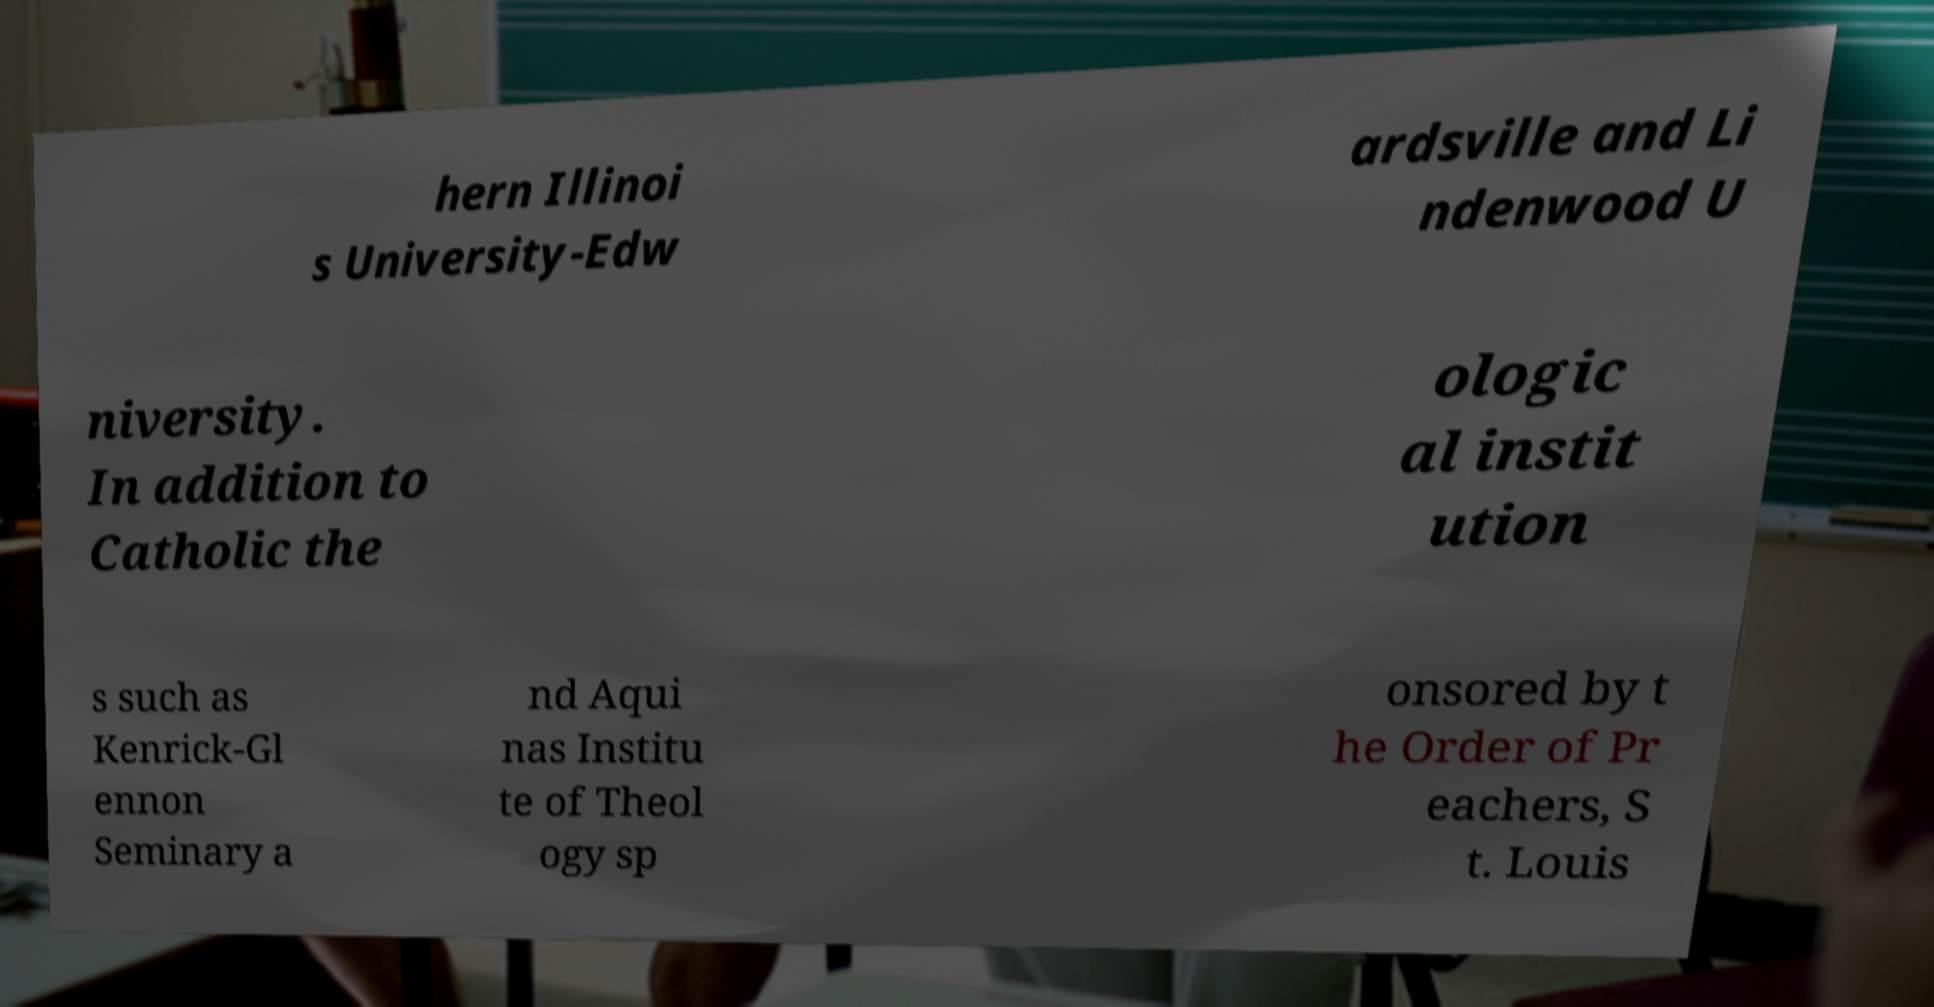For documentation purposes, I need the text within this image transcribed. Could you provide that? hern Illinoi s University-Edw ardsville and Li ndenwood U niversity. In addition to Catholic the ologic al instit ution s such as Kenrick-Gl ennon Seminary a nd Aqui nas Institu te of Theol ogy sp onsored by t he Order of Pr eachers, S t. Louis 